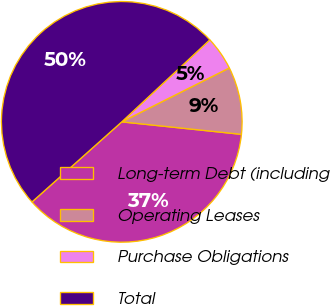Convert chart. <chart><loc_0><loc_0><loc_500><loc_500><pie_chart><fcel>Long-term Debt (including<fcel>Operating Leases<fcel>Purchase Obligations<fcel>Total<nl><fcel>36.75%<fcel>9.05%<fcel>4.54%<fcel>49.65%<nl></chart> 